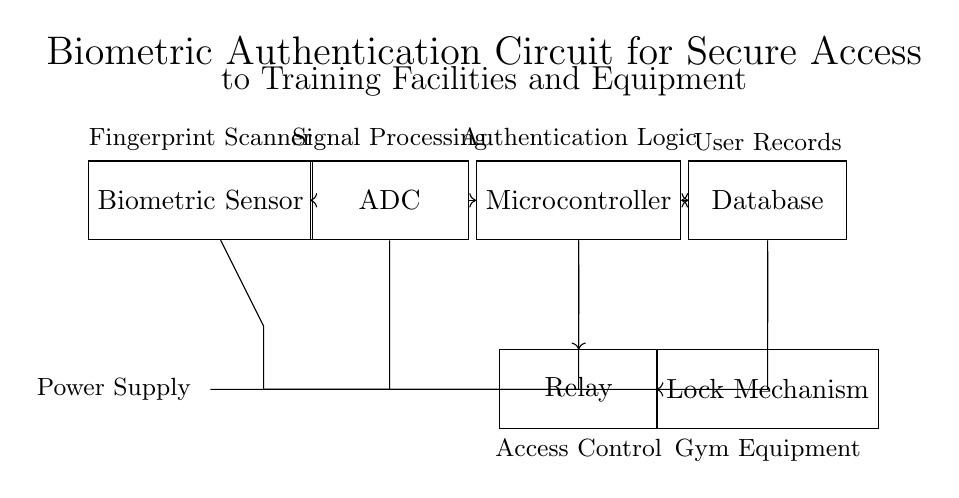What is the first component in the circuit diagram? The first component listed in the diagram is the Biometric Sensor, which is positioned at the leftmost section and is responsible for capturing biometric data.
Answer: Biometric Sensor What does the ADC do in the circuit? The Analog-to-Digital Converter (ADC) in the circuit converts the analog signal from the Biometric Sensor into a digital signal that can be processed by the Microcontroller.
Answer: Converts analog to digital Which component is responsible for authentication logic? The Microcontroller is the component that processes signals and implements the authentication logic based on the data from the ADC and the Database to control access through the Relay.
Answer: Microcontroller How is power supplied to the circuit? Power is supplied by a battery, which is connected to the Biometric Sensor, ADC, Microcontroller, Database, and Relay, indicating that all components draw power from this battery.
Answer: Battery What is the purpose of the Relay in this circuit? The Relay acts as an access control mechanism that receives the signal from the Microcontroller to either engage or disengage the Lock Mechanism, allowing or restricting access to the gym equipment.
Answer: Access control What types of connections exist between the Microcontroller and the Database? The connection between the Microcontroller and the Database is bidirectional, which means the Microcontroller can read user records and send or receive authentication data back and forth to verify access permissions.
Answer: Bidirectional What is the final output of the circuit when access is granted? The final output when access is granted is the activation of the Lock Mechanism, which allows physical access to the training facilities or equipment, effectively controlling who can enter.
Answer: Lock Mechanism 